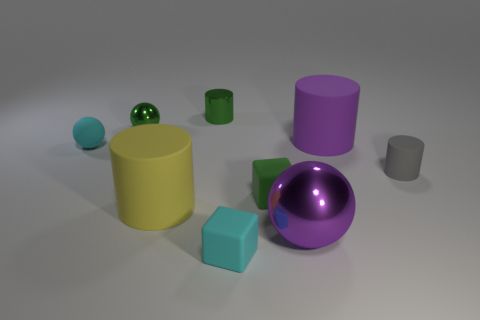Subtract all green spheres. Subtract all purple blocks. How many spheres are left? 2 Add 1 green cylinders. How many objects exist? 10 Subtract all balls. How many objects are left? 6 Subtract 1 gray cylinders. How many objects are left? 8 Subtract all green shiny cylinders. Subtract all cylinders. How many objects are left? 4 Add 2 tiny green spheres. How many tiny green spheres are left? 3 Add 5 large cylinders. How many large cylinders exist? 7 